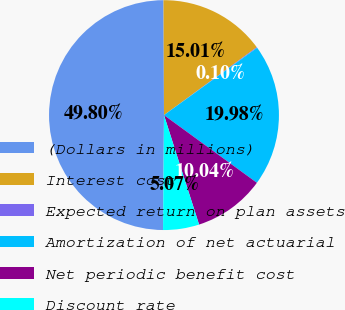Convert chart to OTSL. <chart><loc_0><loc_0><loc_500><loc_500><pie_chart><fcel>(Dollars in millions)<fcel>Interest cost<fcel>Expected return on plan assets<fcel>Amortization of net actuarial<fcel>Net periodic benefit cost<fcel>Discount rate<nl><fcel>49.8%<fcel>15.01%<fcel>0.1%<fcel>19.98%<fcel>10.04%<fcel>5.07%<nl></chart> 